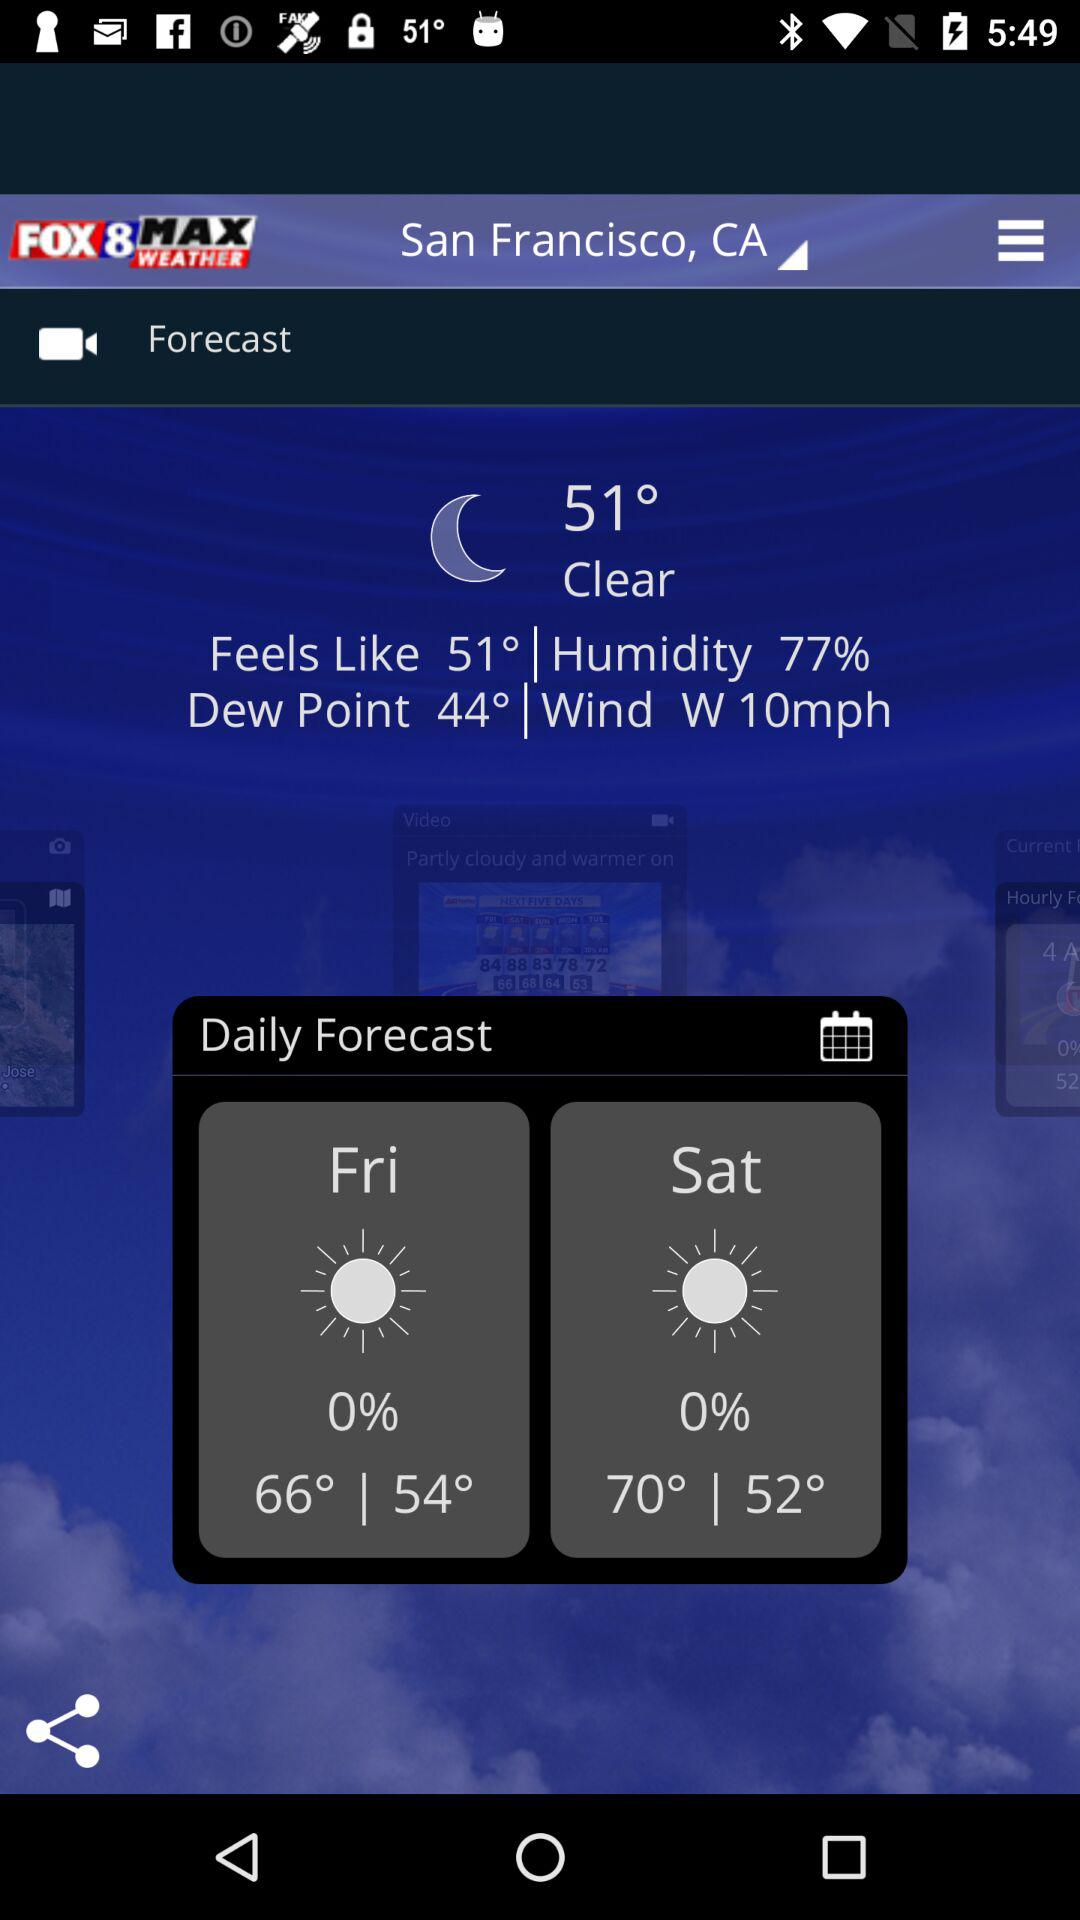What is the name of the application? The name of the application is "Fox8 Max Weather". 